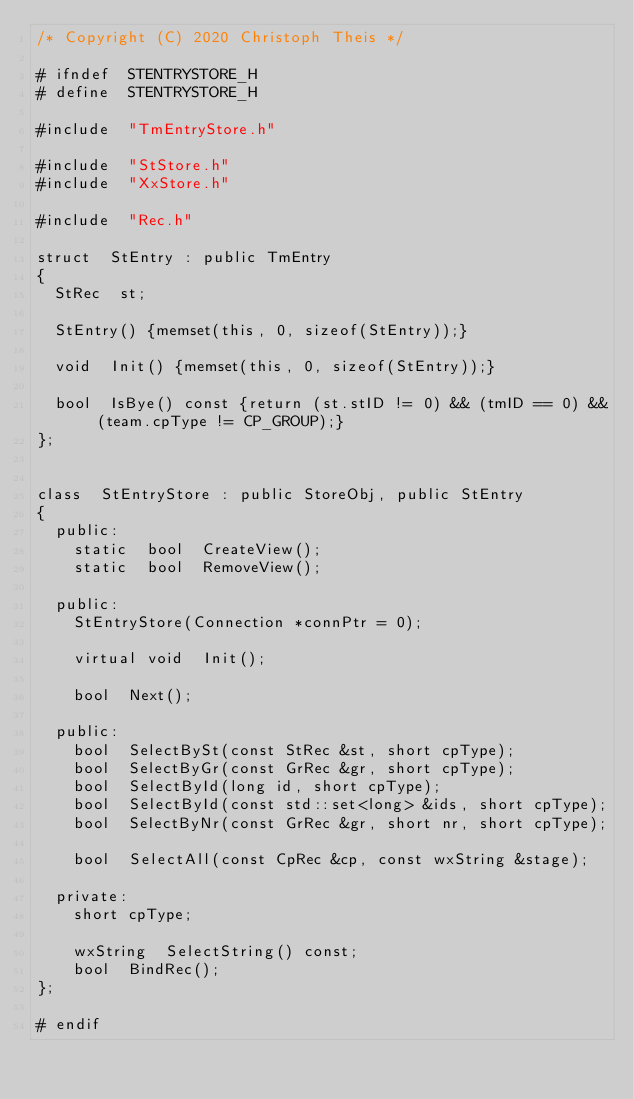<code> <loc_0><loc_0><loc_500><loc_500><_C_>/* Copyright (C) 2020 Christoph Theis */

# ifndef  STENTRYSTORE_H
# define  STENTRYSTORE_H

#include  "TmEntryStore.h"

#include  "StStore.h"
#include  "XxStore.h"

#include  "Rec.h"

struct  StEntry : public TmEntry
{
  StRec  st;

  StEntry() {memset(this, 0, sizeof(StEntry));}

  void  Init() {memset(this, 0, sizeof(StEntry));}

  bool  IsBye() const {return (st.stID != 0) && (tmID == 0) && (team.cpType != CP_GROUP);}
};


class  StEntryStore : public StoreObj, public StEntry
{
  public:
    static  bool  CreateView();
    static  bool  RemoveView();

  public:
    StEntryStore(Connection *connPtr = 0);

    virtual void  Init();

    bool  Next();

  public:
    bool  SelectBySt(const StRec &st, short cpType);
    bool  SelectByGr(const GrRec &gr, short cpType);
    bool  SelectById(long id, short cpType);
    bool  SelectById(const std::set<long> &ids, short cpType);
    bool  SelectByNr(const GrRec &gr, short nr, short cpType);

    bool  SelectAll(const CpRec &cp, const wxString &stage);

  private:
    short cpType;

    wxString  SelectString() const;
    bool  BindRec();
};

# endif
</code> 